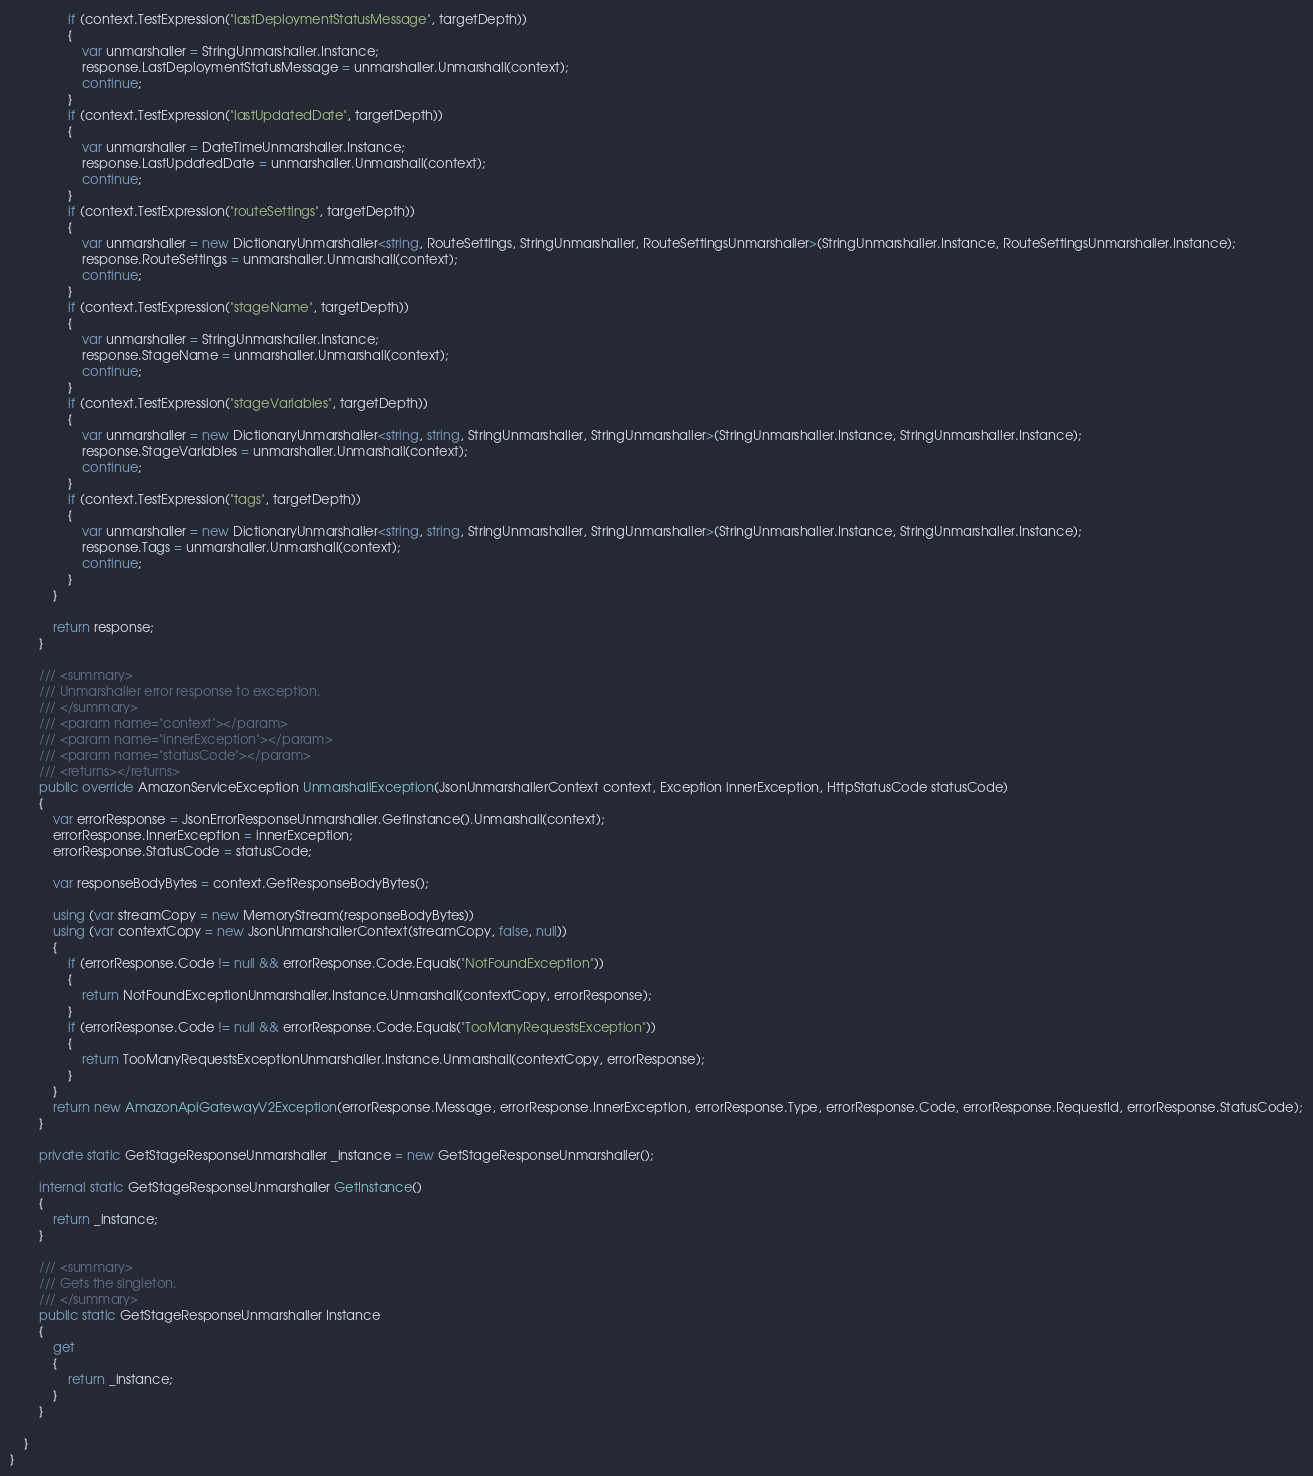Convert code to text. <code><loc_0><loc_0><loc_500><loc_500><_C#_>                if (context.TestExpression("lastDeploymentStatusMessage", targetDepth))
                {
                    var unmarshaller = StringUnmarshaller.Instance;
                    response.LastDeploymentStatusMessage = unmarshaller.Unmarshall(context);
                    continue;
                }
                if (context.TestExpression("lastUpdatedDate", targetDepth))
                {
                    var unmarshaller = DateTimeUnmarshaller.Instance;
                    response.LastUpdatedDate = unmarshaller.Unmarshall(context);
                    continue;
                }
                if (context.TestExpression("routeSettings", targetDepth))
                {
                    var unmarshaller = new DictionaryUnmarshaller<string, RouteSettings, StringUnmarshaller, RouteSettingsUnmarshaller>(StringUnmarshaller.Instance, RouteSettingsUnmarshaller.Instance);
                    response.RouteSettings = unmarshaller.Unmarshall(context);
                    continue;
                }
                if (context.TestExpression("stageName", targetDepth))
                {
                    var unmarshaller = StringUnmarshaller.Instance;
                    response.StageName = unmarshaller.Unmarshall(context);
                    continue;
                }
                if (context.TestExpression("stageVariables", targetDepth))
                {
                    var unmarshaller = new DictionaryUnmarshaller<string, string, StringUnmarshaller, StringUnmarshaller>(StringUnmarshaller.Instance, StringUnmarshaller.Instance);
                    response.StageVariables = unmarshaller.Unmarshall(context);
                    continue;
                }
                if (context.TestExpression("tags", targetDepth))
                {
                    var unmarshaller = new DictionaryUnmarshaller<string, string, StringUnmarshaller, StringUnmarshaller>(StringUnmarshaller.Instance, StringUnmarshaller.Instance);
                    response.Tags = unmarshaller.Unmarshall(context);
                    continue;
                }
            }

            return response;
        }

        /// <summary>
        /// Unmarshaller error response to exception.
        /// </summary>  
        /// <param name="context"></param>
        /// <param name="innerException"></param>
        /// <param name="statusCode"></param>
        /// <returns></returns>
        public override AmazonServiceException UnmarshallException(JsonUnmarshallerContext context, Exception innerException, HttpStatusCode statusCode)
        {
            var errorResponse = JsonErrorResponseUnmarshaller.GetInstance().Unmarshall(context);
            errorResponse.InnerException = innerException;
            errorResponse.StatusCode = statusCode;

            var responseBodyBytes = context.GetResponseBodyBytes();

            using (var streamCopy = new MemoryStream(responseBodyBytes))
            using (var contextCopy = new JsonUnmarshallerContext(streamCopy, false, null))
            {
                if (errorResponse.Code != null && errorResponse.Code.Equals("NotFoundException"))
                {
                    return NotFoundExceptionUnmarshaller.Instance.Unmarshall(contextCopy, errorResponse);
                }
                if (errorResponse.Code != null && errorResponse.Code.Equals("TooManyRequestsException"))
                {
                    return TooManyRequestsExceptionUnmarshaller.Instance.Unmarshall(contextCopy, errorResponse);
                }
            }
            return new AmazonApiGatewayV2Exception(errorResponse.Message, errorResponse.InnerException, errorResponse.Type, errorResponse.Code, errorResponse.RequestId, errorResponse.StatusCode);
        }

        private static GetStageResponseUnmarshaller _instance = new GetStageResponseUnmarshaller();        

        internal static GetStageResponseUnmarshaller GetInstance()
        {
            return _instance;
        }

        /// <summary>
        /// Gets the singleton.
        /// </summary>  
        public static GetStageResponseUnmarshaller Instance
        {
            get
            {
                return _instance;
            }
        }

    }
}</code> 